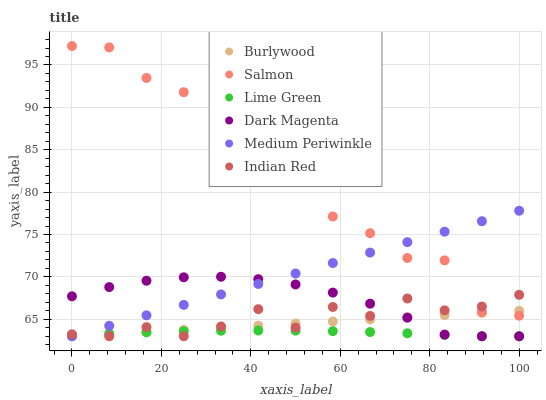Does Lime Green have the minimum area under the curve?
Answer yes or no. Yes. Does Salmon have the maximum area under the curve?
Answer yes or no. Yes. Does Burlywood have the minimum area under the curve?
Answer yes or no. No. Does Burlywood have the maximum area under the curve?
Answer yes or no. No. Is Medium Periwinkle the smoothest?
Answer yes or no. Yes. Is Salmon the roughest?
Answer yes or no. Yes. Is Burlywood the smoothest?
Answer yes or no. No. Is Burlywood the roughest?
Answer yes or no. No. Does Dark Magenta have the lowest value?
Answer yes or no. Yes. Does Salmon have the lowest value?
Answer yes or no. No. Does Salmon have the highest value?
Answer yes or no. Yes. Does Burlywood have the highest value?
Answer yes or no. No. Is Dark Magenta less than Salmon?
Answer yes or no. Yes. Is Salmon greater than Dark Magenta?
Answer yes or no. Yes. Does Burlywood intersect Salmon?
Answer yes or no. Yes. Is Burlywood less than Salmon?
Answer yes or no. No. Is Burlywood greater than Salmon?
Answer yes or no. No. Does Dark Magenta intersect Salmon?
Answer yes or no. No. 